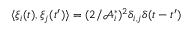<formula> <loc_0><loc_0><loc_500><loc_500>\langle \xi _ { i } ( t ) , \xi _ { j } ( t ^ { \prime } ) \rangle = ( 2 / \mathcal { A } _ { i } ^ { * } ) ^ { 2 } \delta _ { i , j } \delta ( t - t ^ { \prime } )</formula> 